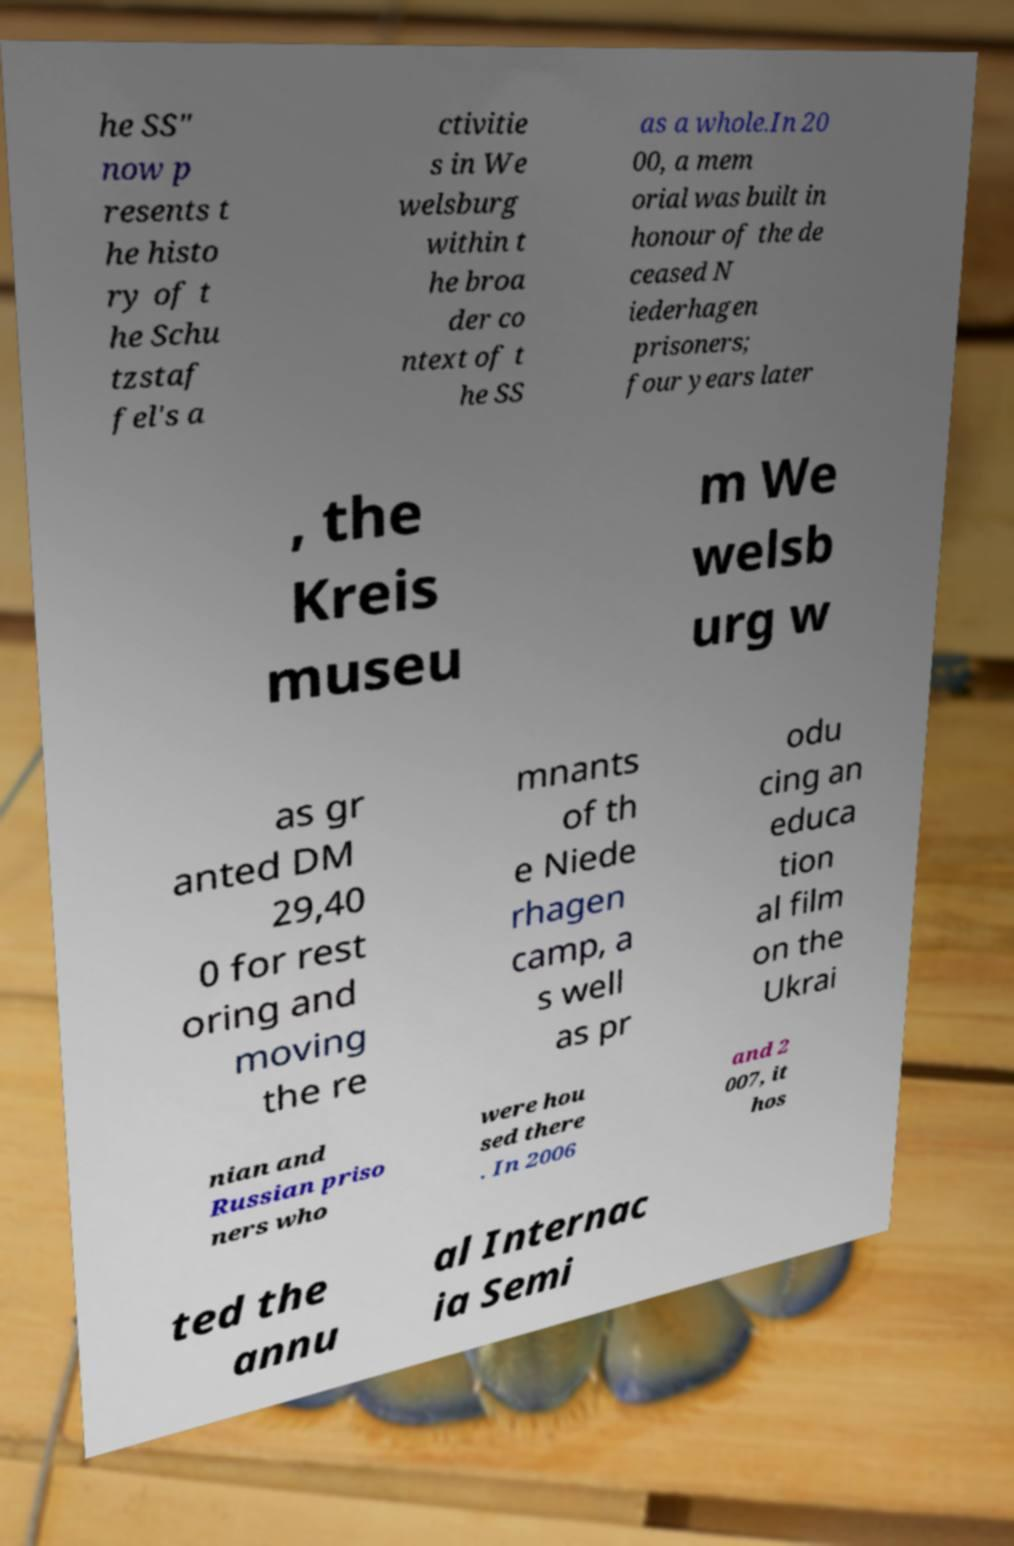There's text embedded in this image that I need extracted. Can you transcribe it verbatim? he SS" now p resents t he histo ry of t he Schu tzstaf fel's a ctivitie s in We welsburg within t he broa der co ntext of t he SS as a whole.In 20 00, a mem orial was built in honour of the de ceased N iederhagen prisoners; four years later , the Kreis museu m We welsb urg w as gr anted DM 29,40 0 for rest oring and moving the re mnants of th e Niede rhagen camp, a s well as pr odu cing an educa tion al film on the Ukrai nian and Russian priso ners who were hou sed there . In 2006 and 2 007, it hos ted the annu al Internac ia Semi 